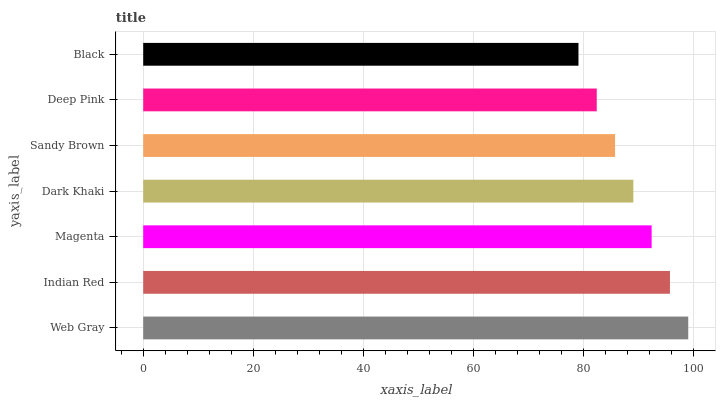Is Black the minimum?
Answer yes or no. Yes. Is Web Gray the maximum?
Answer yes or no. Yes. Is Indian Red the minimum?
Answer yes or no. No. Is Indian Red the maximum?
Answer yes or no. No. Is Web Gray greater than Indian Red?
Answer yes or no. Yes. Is Indian Red less than Web Gray?
Answer yes or no. Yes. Is Indian Red greater than Web Gray?
Answer yes or no. No. Is Web Gray less than Indian Red?
Answer yes or no. No. Is Dark Khaki the high median?
Answer yes or no. Yes. Is Dark Khaki the low median?
Answer yes or no. Yes. Is Deep Pink the high median?
Answer yes or no. No. Is Magenta the low median?
Answer yes or no. No. 